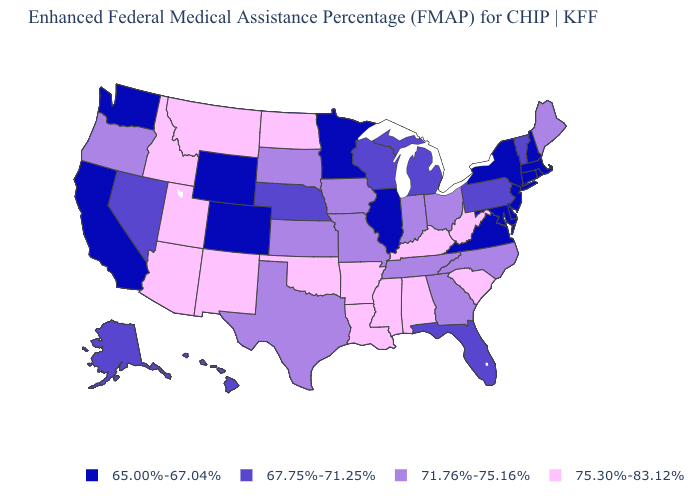What is the value of Tennessee?
Concise answer only. 71.76%-75.16%. Name the states that have a value in the range 71.76%-75.16%?
Give a very brief answer. Georgia, Indiana, Iowa, Kansas, Maine, Missouri, North Carolina, Ohio, Oregon, South Dakota, Tennessee, Texas. What is the value of Rhode Island?
Short answer required. 65.00%-67.04%. Which states hav the highest value in the West?
Be succinct. Arizona, Idaho, Montana, New Mexico, Utah. Does the map have missing data?
Concise answer only. No. Which states have the highest value in the USA?
Be succinct. Alabama, Arizona, Arkansas, Idaho, Kentucky, Louisiana, Mississippi, Montana, New Mexico, North Dakota, Oklahoma, South Carolina, Utah, West Virginia. Name the states that have a value in the range 75.30%-83.12%?
Short answer required. Alabama, Arizona, Arkansas, Idaho, Kentucky, Louisiana, Mississippi, Montana, New Mexico, North Dakota, Oklahoma, South Carolina, Utah, West Virginia. Does Missouri have the highest value in the USA?
Keep it brief. No. Does California have the same value as Utah?
Short answer required. No. Name the states that have a value in the range 71.76%-75.16%?
Give a very brief answer. Georgia, Indiana, Iowa, Kansas, Maine, Missouri, North Carolina, Ohio, Oregon, South Dakota, Tennessee, Texas. Name the states that have a value in the range 67.75%-71.25%?
Short answer required. Alaska, Florida, Hawaii, Michigan, Nebraska, Nevada, Pennsylvania, Vermont, Wisconsin. Does Arizona have the highest value in the USA?
Quick response, please. Yes. How many symbols are there in the legend?
Quick response, please. 4. Name the states that have a value in the range 75.30%-83.12%?
Answer briefly. Alabama, Arizona, Arkansas, Idaho, Kentucky, Louisiana, Mississippi, Montana, New Mexico, North Dakota, Oklahoma, South Carolina, Utah, West Virginia. What is the value of Texas?
Short answer required. 71.76%-75.16%. 